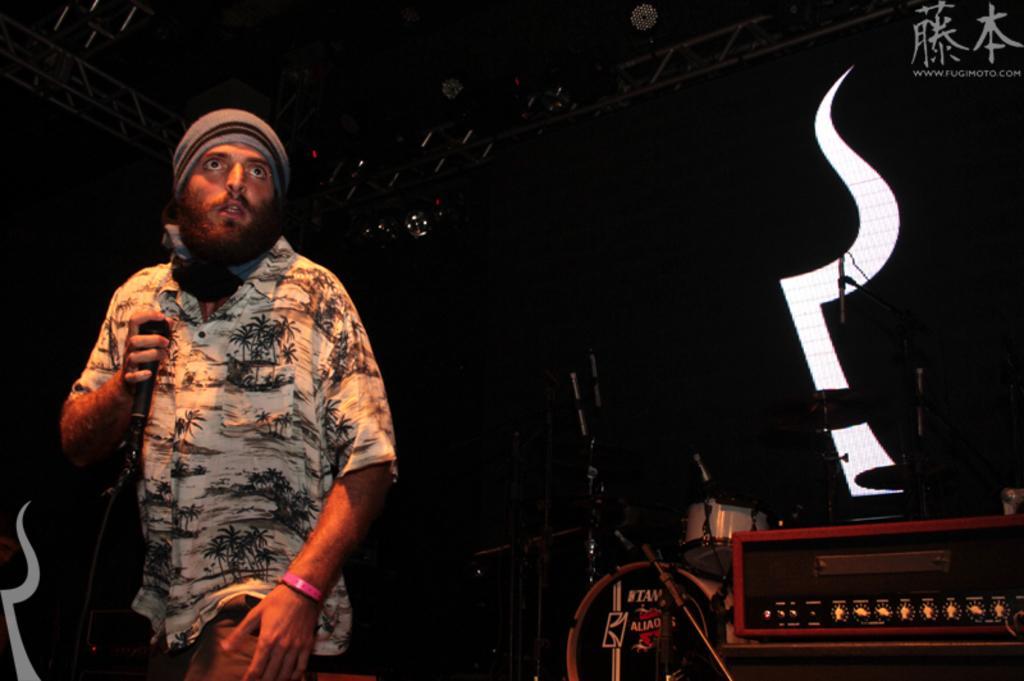Describe this image in one or two sentences. In this picture there is a man wearing a white color shirt is standing and singing the sing. Beside there is a music band. Behind there is a dark background. On the top there is a metal frame with spotlight. 